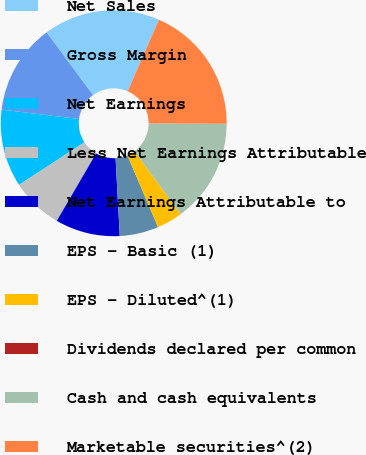<chart> <loc_0><loc_0><loc_500><loc_500><pie_chart><fcel>Net Sales<fcel>Gross Margin<fcel>Net Earnings<fcel>Less Net Earnings Attributable<fcel>Net Earnings Attributable to<fcel>EPS - Basic (1)<fcel>EPS - Diluted^(1)<fcel>Dividends declared per common<fcel>Cash and cash equivalents<fcel>Marketable securities^(2)<nl><fcel>16.67%<fcel>12.96%<fcel>11.11%<fcel>7.41%<fcel>9.26%<fcel>5.56%<fcel>3.7%<fcel>0.0%<fcel>14.81%<fcel>18.52%<nl></chart> 